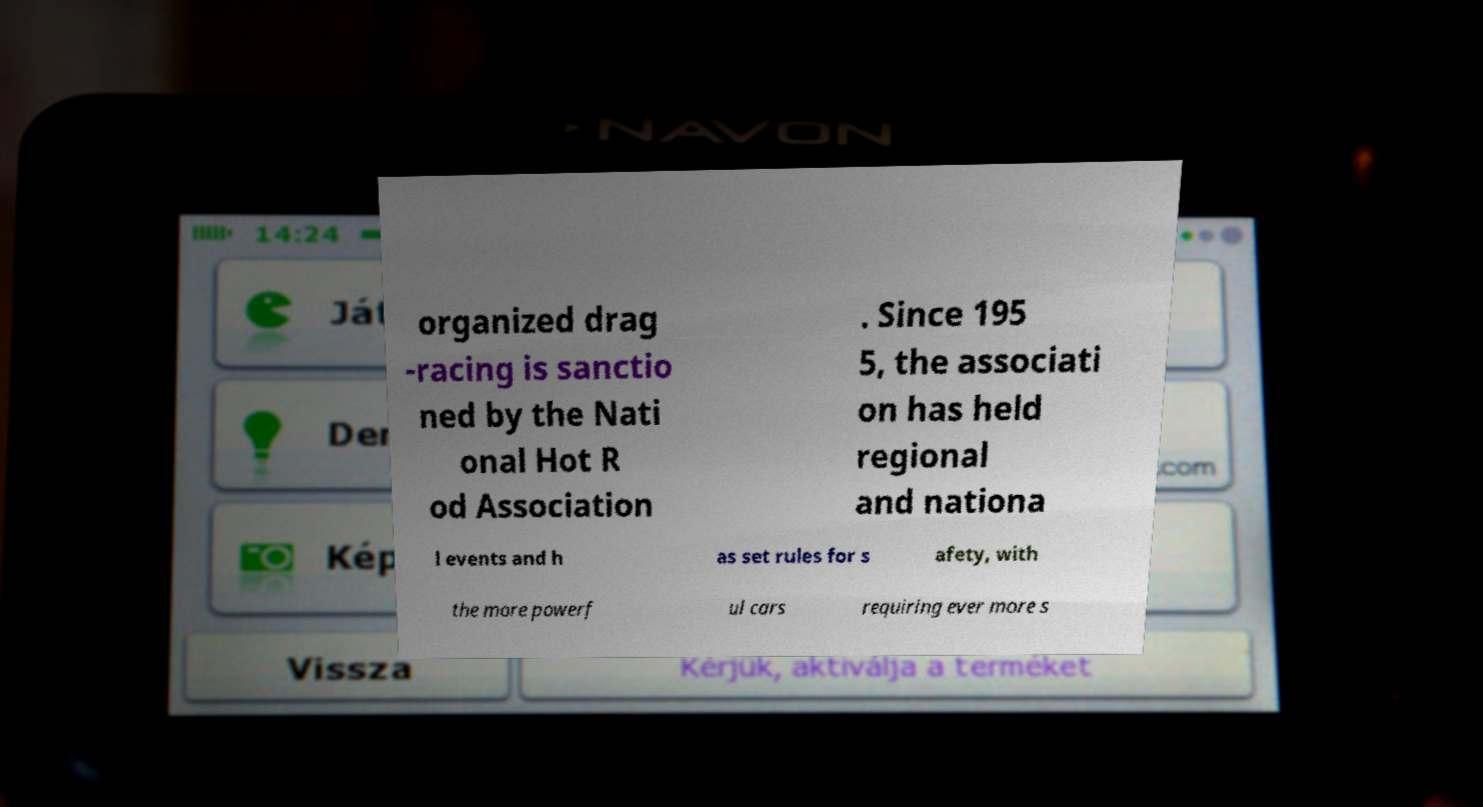Please read and relay the text visible in this image. What does it say? organized drag -racing is sanctio ned by the Nati onal Hot R od Association . Since 195 5, the associati on has held regional and nationa l events and h as set rules for s afety, with the more powerf ul cars requiring ever more s 